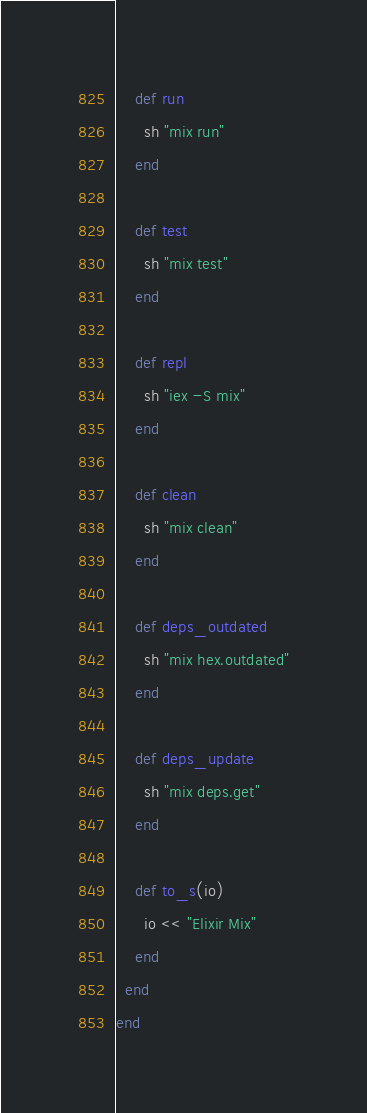<code> <loc_0><loc_0><loc_500><loc_500><_Crystal_>
    def run
      sh "mix run"
    end

    def test
      sh "mix test"
    end

    def repl
      sh "iex -S mix"
    end

    def clean
      sh "mix clean"
    end

    def deps_outdated
      sh "mix hex.outdated"
    end

    def deps_update
      sh "mix deps.get"
    end

    def to_s(io)
      io << "Elixir Mix"
    end
  end
end
</code> 